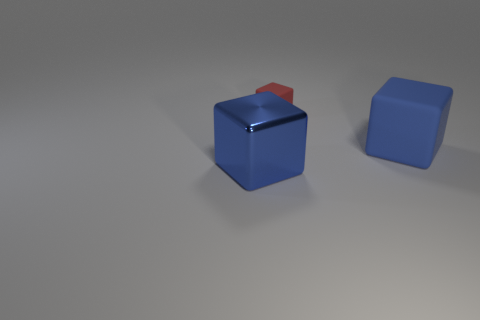There is a shiny object on the left side of the red block; is it the same size as the small red block?
Make the answer very short. No. Is the number of tiny red matte blocks less than the number of small cyan rubber cubes?
Offer a very short reply. No. Is the number of red rubber things greater than the number of big red matte objects?
Your response must be concise. Yes. How many other objects are there of the same material as the small object?
Your response must be concise. 1. What number of big things are behind the big cube right of the object that is to the left of the red thing?
Offer a terse response. 0. How many rubber objects are either large cubes or tiny gray cylinders?
Provide a succinct answer. 1. There is a thing right of the rubber object behind the big blue rubber block; what is its size?
Your response must be concise. Large. There is a big thing that is behind the big blue metallic cube; does it have the same color as the large cube that is to the left of the small red object?
Offer a very short reply. Yes. There is a block that is both to the left of the large matte thing and on the right side of the blue metal block; what is its color?
Your response must be concise. Red. How many large objects are either red objects or gray rubber objects?
Your response must be concise. 0. 